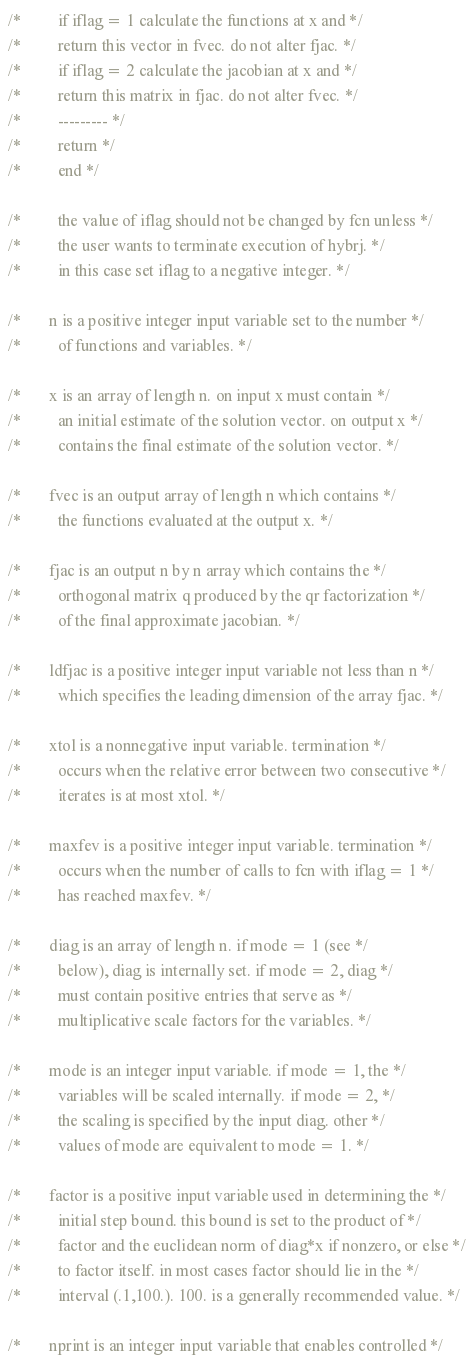<code> <loc_0><loc_0><loc_500><loc_500><_C_>/*         if iflag = 1 calculate the functions at x and */
/*         return this vector in fvec. do not alter fjac. */
/*         if iflag = 2 calculate the jacobian at x and */
/*         return this matrix in fjac. do not alter fvec. */
/*         --------- */
/*         return */
/*         end */

/*         the value of iflag should not be changed by fcn unless */
/*         the user wants to terminate execution of hybrj. */
/*         in this case set iflag to a negative integer. */

/*       n is a positive integer input variable set to the number */
/*         of functions and variables. */

/*       x is an array of length n. on input x must contain */
/*         an initial estimate of the solution vector. on output x */
/*         contains the final estimate of the solution vector. */

/*       fvec is an output array of length n which contains */
/*         the functions evaluated at the output x. */

/*       fjac is an output n by n array which contains the */
/*         orthogonal matrix q produced by the qr factorization */
/*         of the final approximate jacobian. */

/*       ldfjac is a positive integer input variable not less than n */
/*         which specifies the leading dimension of the array fjac. */

/*       xtol is a nonnegative input variable. termination */
/*         occurs when the relative error between two consecutive */
/*         iterates is at most xtol. */

/*       maxfev is a positive integer input variable. termination */
/*         occurs when the number of calls to fcn with iflag = 1 */
/*         has reached maxfev. */

/*       diag is an array of length n. if mode = 1 (see */
/*         below), diag is internally set. if mode = 2, diag */
/*         must contain positive entries that serve as */
/*         multiplicative scale factors for the variables. */

/*       mode is an integer input variable. if mode = 1, the */
/*         variables will be scaled internally. if mode = 2, */
/*         the scaling is specified by the input diag. other */
/*         values of mode are equivalent to mode = 1. */

/*       factor is a positive input variable used in determining the */
/*         initial step bound. this bound is set to the product of */
/*         factor and the euclidean norm of diag*x if nonzero, or else */
/*         to factor itself. in most cases factor should lie in the */
/*         interval (.1,100.). 100. is a generally recommended value. */

/*       nprint is an integer input variable that enables controlled */</code> 